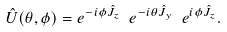Convert formula to latex. <formula><loc_0><loc_0><loc_500><loc_500>\hat { U } ( \theta , \phi ) = e ^ { - i \phi \hat { J } _ { z } } \ e ^ { - i \theta \hat { J } _ { y } } \ e ^ { i \phi \hat { J } _ { z } } .</formula> 